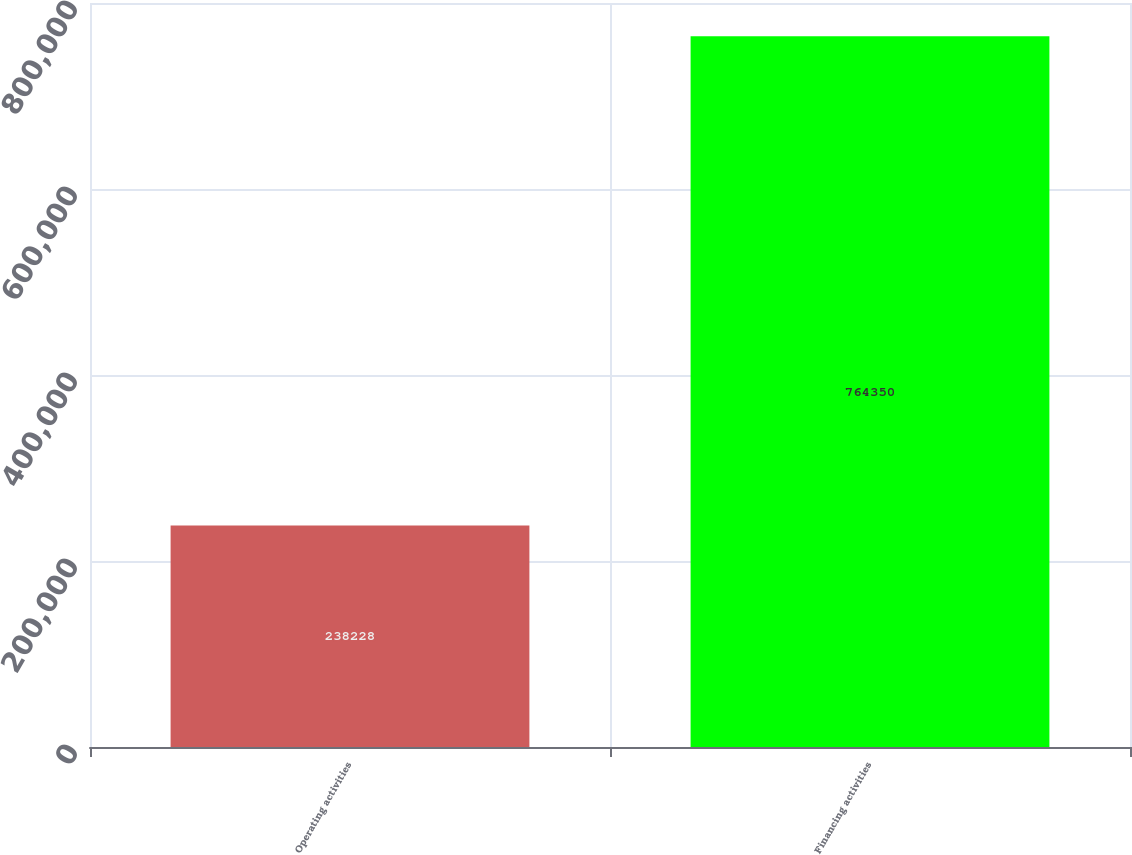Convert chart to OTSL. <chart><loc_0><loc_0><loc_500><loc_500><bar_chart><fcel>Operating activities<fcel>Financing activities<nl><fcel>238228<fcel>764350<nl></chart> 